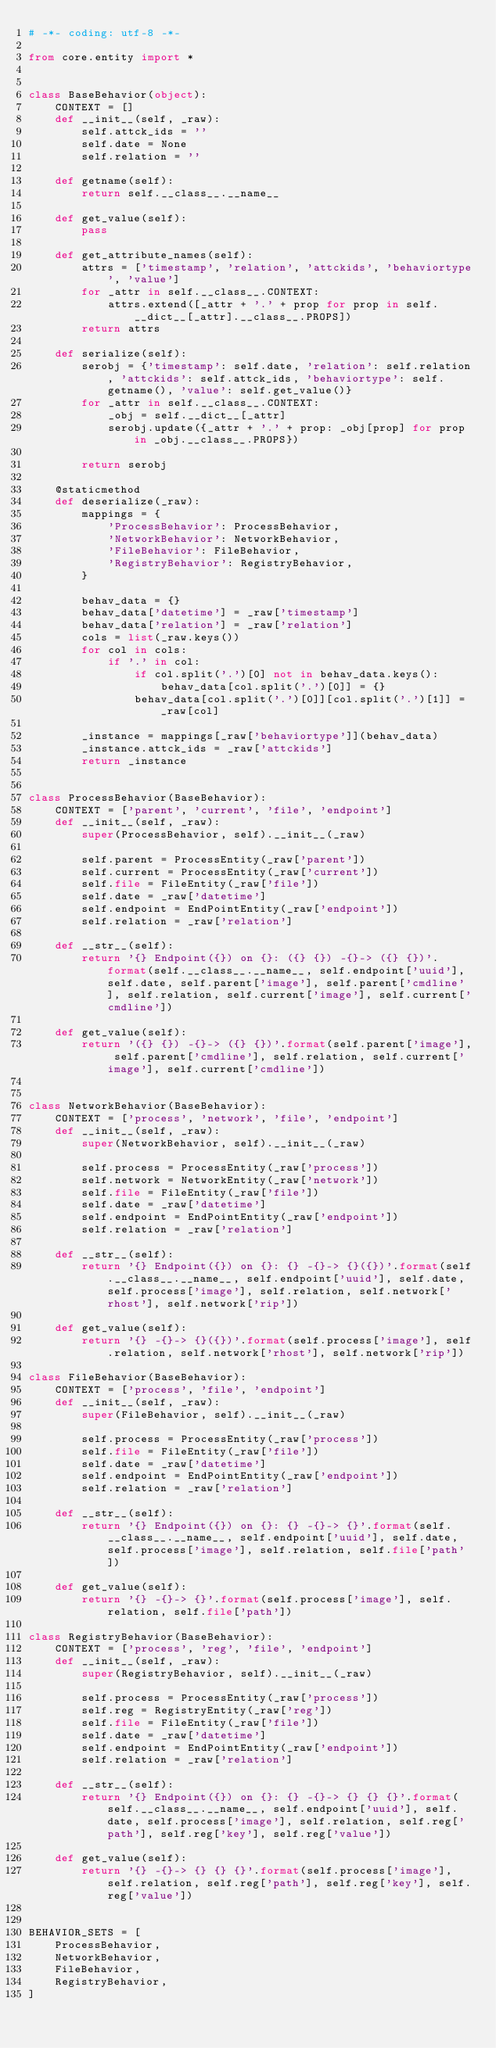<code> <loc_0><loc_0><loc_500><loc_500><_Python_># -*- coding: utf-8 -*-

from core.entity import *


class BaseBehavior(object):
    CONTEXT = []
    def __init__(self, _raw):
        self.attck_ids = ''
        self.date = None
        self.relation = ''

    def getname(self):
        return self.__class__.__name__

    def get_value(self):
        pass

    def get_attribute_names(self):
        attrs = ['timestamp', 'relation', 'attckids', 'behaviortype', 'value']
        for _attr in self.__class__.CONTEXT:
            attrs.extend([_attr + '.' + prop for prop in self.__dict__[_attr].__class__.PROPS])
        return attrs

    def serialize(self):
        serobj = {'timestamp': self.date, 'relation': self.relation, 'attckids': self.attck_ids, 'behaviortype': self.getname(), 'value': self.get_value()}
        for _attr in self.__class__.CONTEXT:
            _obj = self.__dict__[_attr]
            serobj.update({_attr + '.' + prop: _obj[prop] for prop in _obj.__class__.PROPS})

        return serobj

    @staticmethod
    def deserialize(_raw):
        mappings = {
            'ProcessBehavior': ProcessBehavior,
            'NetworkBehavior': NetworkBehavior,
            'FileBehavior': FileBehavior,
            'RegistryBehavior': RegistryBehavior,
        }
        
        behav_data = {}
        behav_data['datetime'] = _raw['timestamp']
        behav_data['relation'] = _raw['relation']
        cols = list(_raw.keys())
        for col in cols:
            if '.' in col:
                if col.split('.')[0] not in behav_data.keys():
                    behav_data[col.split('.')[0]] = {}
                behav_data[col.split('.')[0]][col.split('.')[1]] = _raw[col]

        _instance = mappings[_raw['behaviortype']](behav_data)
        _instance.attck_ids = _raw['attckids']
        return _instance


class ProcessBehavior(BaseBehavior):
    CONTEXT = ['parent', 'current', 'file', 'endpoint']
    def __init__(self, _raw):
        super(ProcessBehavior, self).__init__(_raw)

        self.parent = ProcessEntity(_raw['parent'])
        self.current = ProcessEntity(_raw['current'])
        self.file = FileEntity(_raw['file'])
        self.date = _raw['datetime']
        self.endpoint = EndPointEntity(_raw['endpoint'])
        self.relation = _raw['relation']

    def __str__(self):
        return '{} Endpoint({}) on {}: ({} {}) -{}-> ({} {})'.format(self.__class__.__name__, self.endpoint['uuid'], self.date, self.parent['image'], self.parent['cmdline'], self.relation, self.current['image'], self.current['cmdline'])

    def get_value(self):
        return '({} {}) -{}-> ({} {})'.format(self.parent['image'], self.parent['cmdline'], self.relation, self.current['image'], self.current['cmdline'])


class NetworkBehavior(BaseBehavior):
    CONTEXT = ['process', 'network', 'file', 'endpoint']
    def __init__(self, _raw):
        super(NetworkBehavior, self).__init__(_raw)

        self.process = ProcessEntity(_raw['process'])
        self.network = NetworkEntity(_raw['network'])
        self.file = FileEntity(_raw['file'])
        self.date = _raw['datetime']
        self.endpoint = EndPointEntity(_raw['endpoint'])
        self.relation = _raw['relation']

    def __str__(self):
        return '{} Endpoint({}) on {}: {} -{}-> {}({})'.format(self.__class__.__name__, self.endpoint['uuid'], self.date, self.process['image'], self.relation, self.network['rhost'], self.network['rip'])

    def get_value(self):
        return '{} -{}-> {}({})'.format(self.process['image'], self.relation, self.network['rhost'], self.network['rip'])

class FileBehavior(BaseBehavior):
    CONTEXT = ['process', 'file', 'endpoint']
    def __init__(self, _raw):
        super(FileBehavior, self).__init__(_raw)

        self.process = ProcessEntity(_raw['process'])
        self.file = FileEntity(_raw['file'])
        self.date = _raw['datetime']
        self.endpoint = EndPointEntity(_raw['endpoint'])
        self.relation = _raw['relation']

    def __str__(self):
        return '{} Endpoint({}) on {}: {} -{}-> {}'.format(self.__class__.__name__, self.endpoint['uuid'], self.date, self.process['image'], self.relation, self.file['path'])

    def get_value(self):
        return '{} -{}-> {}'.format(self.process['image'], self.relation, self.file['path'])

class RegistryBehavior(BaseBehavior):
    CONTEXT = ['process', 'reg', 'file', 'endpoint']
    def __init__(self, _raw):
        super(RegistryBehavior, self).__init__(_raw)

        self.process = ProcessEntity(_raw['process'])
        self.reg = RegistryEntity(_raw['reg'])
        self.file = FileEntity(_raw['file'])
        self.date = _raw['datetime']
        self.endpoint = EndPointEntity(_raw['endpoint'])
        self.relation = _raw['relation']

    def __str__(self):
        return '{} Endpoint({}) on {}: {} -{}-> {} {} {}'.format(self.__class__.__name__, self.endpoint['uuid'], self.date, self.process['image'], self.relation, self.reg['path'], self.reg['key'], self.reg['value'])

    def get_value(self):
        return '{} -{}-> {} {} {}'.format(self.process['image'], self.relation, self.reg['path'], self.reg['key'], self.reg['value'])


BEHAVIOR_SETS = [
    ProcessBehavior,
    NetworkBehavior,
    FileBehavior,
    RegistryBehavior,
]</code> 